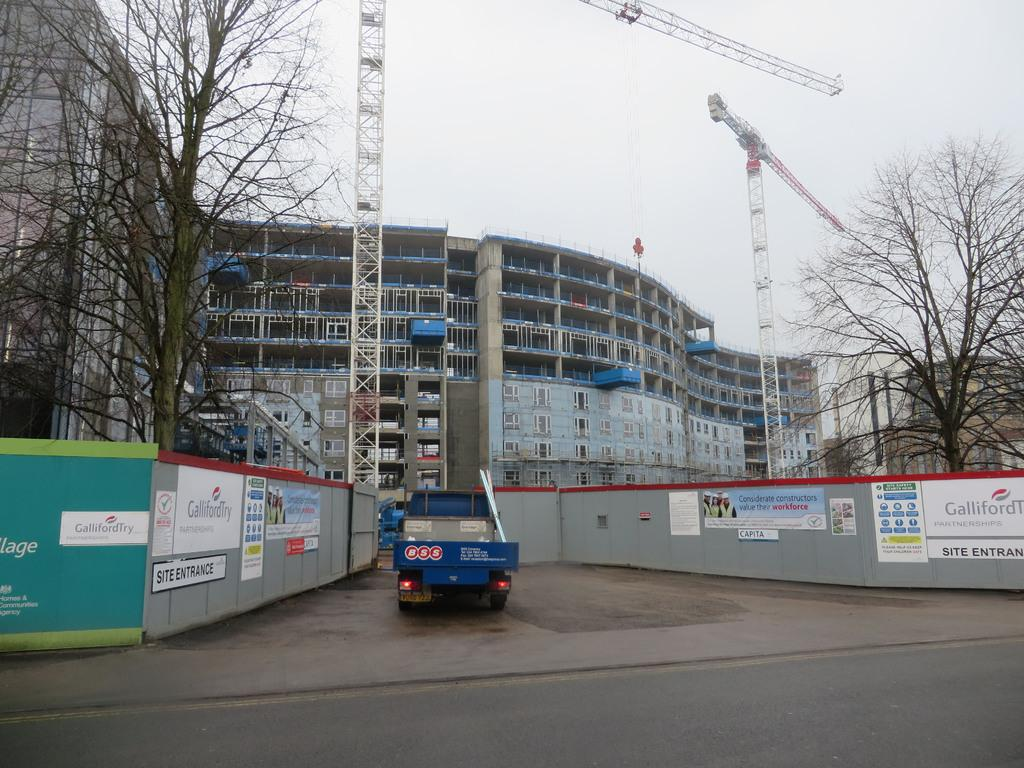What type of structures can be seen in the image? There are buildings in the image. What other natural elements are present in the image? There are trees in the image. Are there any construction vehicles or equipment visible? Yes, there are cranes in the image. What type of vehicle is present in the image? There is a truck in the image. How would you describe the weather based on the image? The sky is cloudy in the image. What type of signage or information is present in the image? There are boards with text in the image. Can you see any plastic materials being used by the giants in the image? There are no giants present in the image, and therefore no plastic materials being used by them. What type of fan is visible in the image? There is no fan present in the image. 